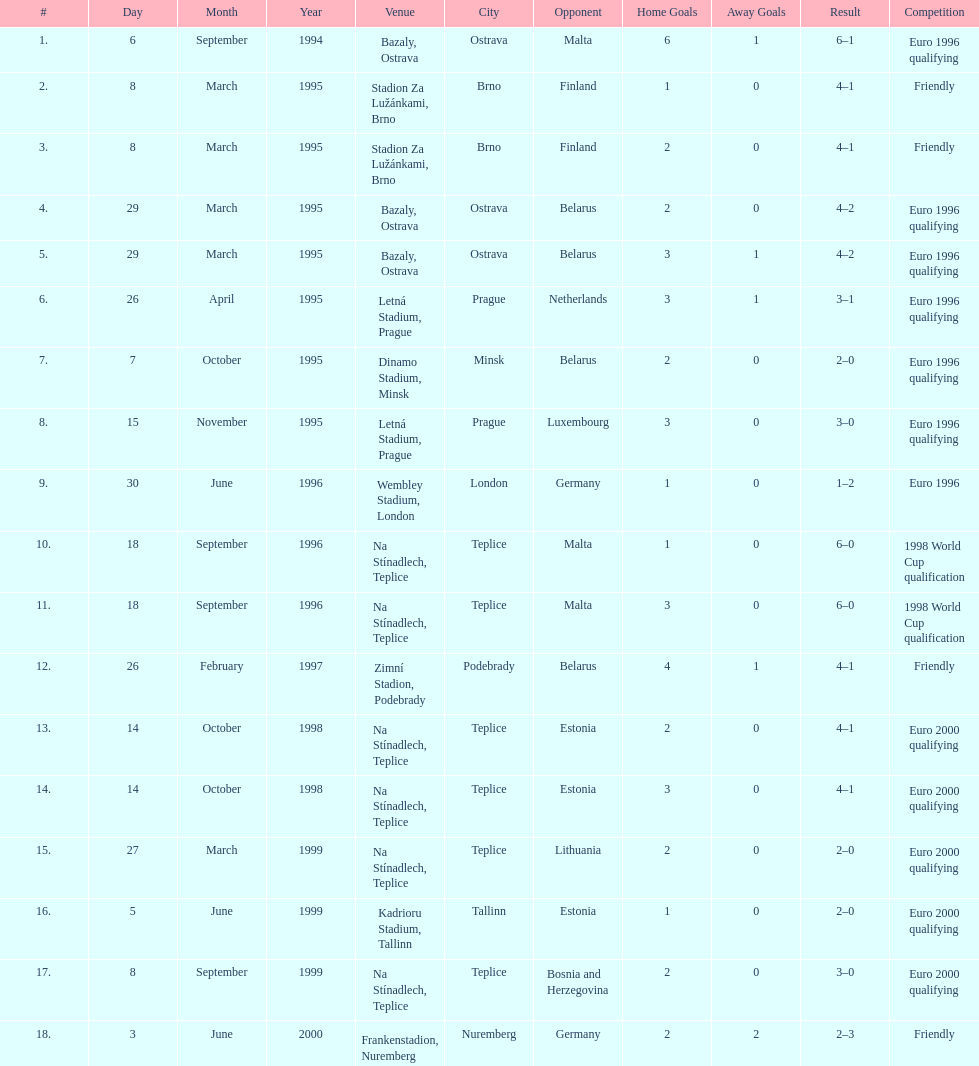How many games took place in ostrava? 2. 